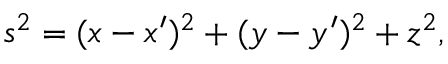<formula> <loc_0><loc_0><loc_500><loc_500>s ^ { 2 } = ( x - x ^ { \prime } ) ^ { 2 } + ( y - y ^ { \prime } ) ^ { 2 } + z ^ { 2 } ,</formula> 